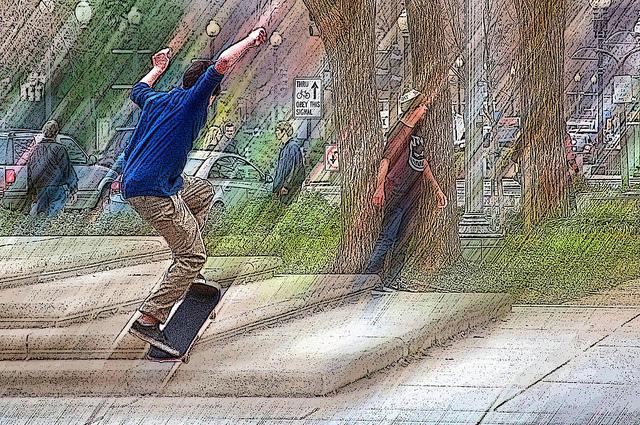How many people can you see?
Give a very brief answer. 3. How many skateboards are there?
Give a very brief answer. 1. How many cars are there?
Give a very brief answer. 2. 